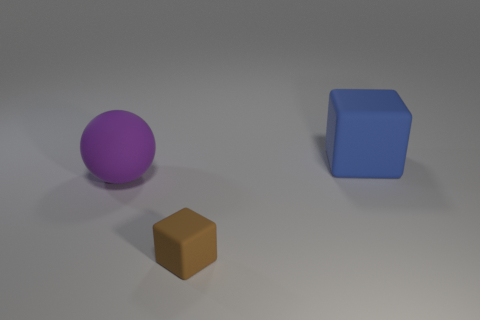There is another matte thing that is the same size as the blue object; what is its shape?
Your answer should be very brief. Sphere. Is the size of the purple ball the same as the blue rubber cube?
Make the answer very short. Yes. What number of other tiny matte cubes have the same color as the small rubber cube?
Your answer should be very brief. 0. What number of big things are either gray rubber blocks or brown cubes?
Offer a very short reply. 0. Are there any other big rubber objects that have the same shape as the big purple matte thing?
Offer a very short reply. No. Is the shape of the big purple matte thing the same as the blue thing?
Your answer should be very brief. No. There is a large rubber thing to the right of the big thing that is on the left side of the brown rubber object; what is its color?
Offer a very short reply. Blue. There is a matte cube that is the same size as the purple object; what color is it?
Offer a very short reply. Blue. What number of metal objects are either big purple balls or tiny brown spheres?
Ensure brevity in your answer.  0. How many large purple objects are right of the big thing left of the tiny thing?
Offer a very short reply. 0. 